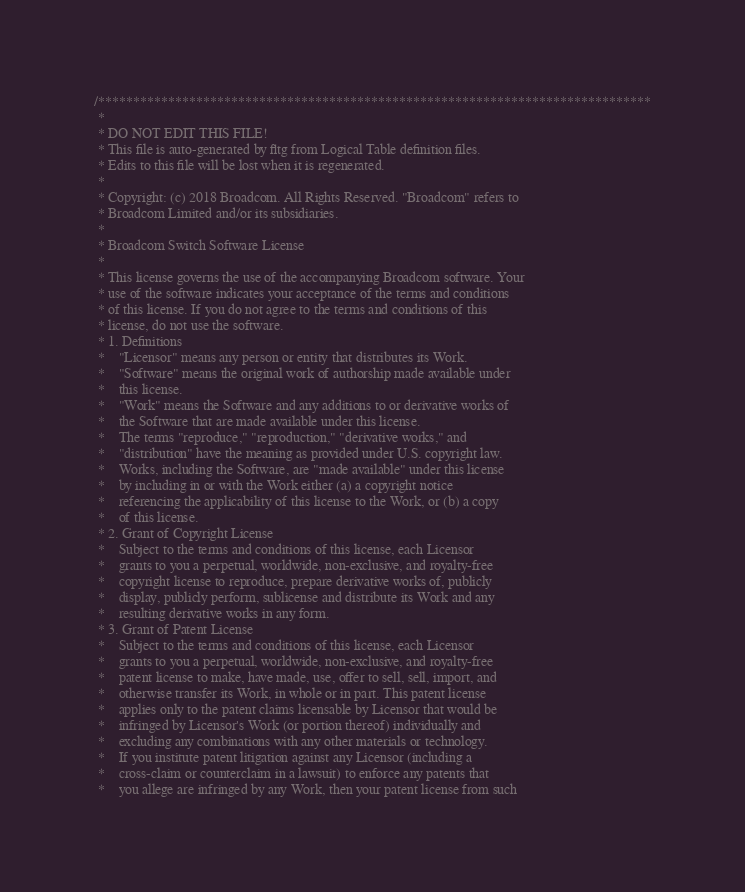Convert code to text. <code><loc_0><loc_0><loc_500><loc_500><_C_>/*******************************************************************************
 *
 * DO NOT EDIT THIS FILE!
 * This file is auto-generated by fltg from Logical Table definition files.
 * Edits to this file will be lost when it is regenerated.
 *
 * Copyright: (c) 2018 Broadcom. All Rights Reserved. "Broadcom" refers to 
 * Broadcom Limited and/or its subsidiaries.
 * 
 * Broadcom Switch Software License
 * 
 * This license governs the use of the accompanying Broadcom software. Your 
 * use of the software indicates your acceptance of the terms and conditions 
 * of this license. If you do not agree to the terms and conditions of this 
 * license, do not use the software.
 * 1. Definitions
 *    "Licensor" means any person or entity that distributes its Work.
 *    "Software" means the original work of authorship made available under 
 *    this license.
 *    "Work" means the Software and any additions to or derivative works of 
 *    the Software that are made available under this license.
 *    The terms "reproduce," "reproduction," "derivative works," and 
 *    "distribution" have the meaning as provided under U.S. copyright law.
 *    Works, including the Software, are "made available" under this license 
 *    by including in or with the Work either (a) a copyright notice 
 *    referencing the applicability of this license to the Work, or (b) a copy 
 *    of this license.
 * 2. Grant of Copyright License
 *    Subject to the terms and conditions of this license, each Licensor 
 *    grants to you a perpetual, worldwide, non-exclusive, and royalty-free 
 *    copyright license to reproduce, prepare derivative works of, publicly 
 *    display, publicly perform, sublicense and distribute its Work and any 
 *    resulting derivative works in any form.
 * 3. Grant of Patent License
 *    Subject to the terms and conditions of this license, each Licensor 
 *    grants to you a perpetual, worldwide, non-exclusive, and royalty-free 
 *    patent license to make, have made, use, offer to sell, sell, import, and 
 *    otherwise transfer its Work, in whole or in part. This patent license 
 *    applies only to the patent claims licensable by Licensor that would be 
 *    infringed by Licensor's Work (or portion thereof) individually and 
 *    excluding any combinations with any other materials or technology.
 *    If you institute patent litigation against any Licensor (including a 
 *    cross-claim or counterclaim in a lawsuit) to enforce any patents that 
 *    you allege are infringed by any Work, then your patent license from such </code> 